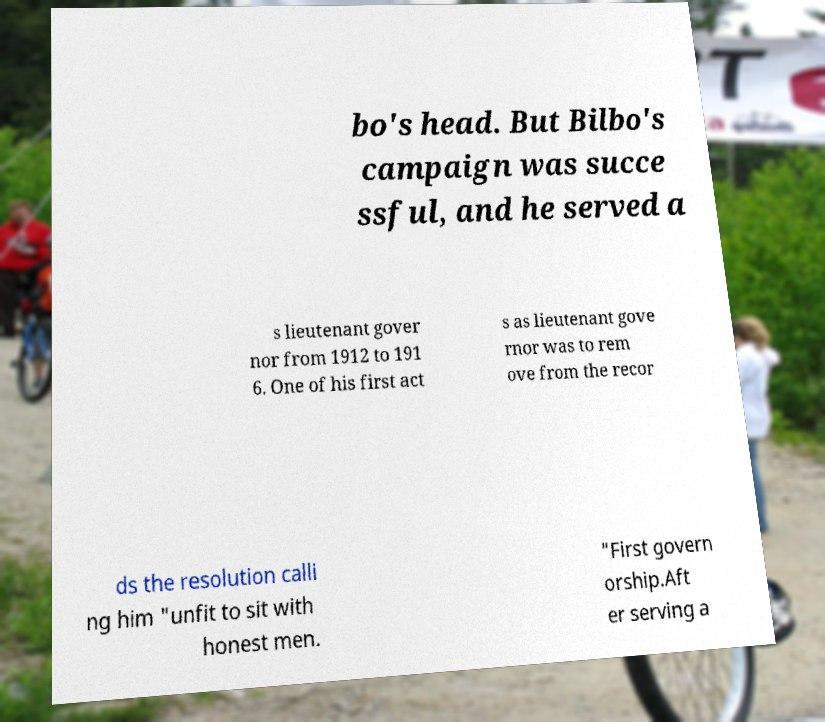Can you accurately transcribe the text from the provided image for me? bo's head. But Bilbo's campaign was succe ssful, and he served a s lieutenant gover nor from 1912 to 191 6. One of his first act s as lieutenant gove rnor was to rem ove from the recor ds the resolution calli ng him "unfit to sit with honest men. "First govern orship.Aft er serving a 